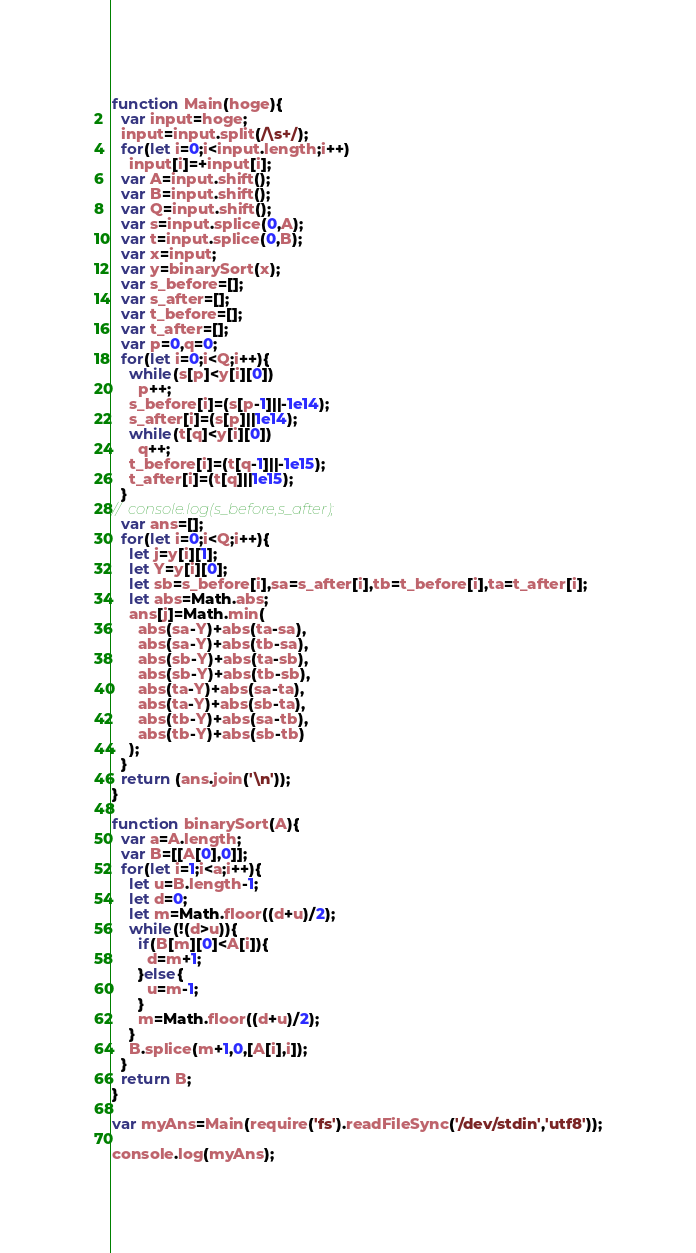<code> <loc_0><loc_0><loc_500><loc_500><_JavaScript_>function Main(hoge){
  var input=hoge;
  input=input.split(/\s+/);
  for(let i=0;i<input.length;i++)
    input[i]=+input[i];
  var A=input.shift();
  var B=input.shift();
  var Q=input.shift();
  var s=input.splice(0,A);
  var t=input.splice(0,B);
  var x=input;
  var y=binarySort(x);
  var s_before=[];
  var s_after=[];
  var t_before=[];
  var t_after=[];
  var p=0,q=0;
  for(let i=0;i<Q;i++){
    while(s[p]<y[i][0])
      p++;
    s_before[i]=(s[p-1]||-1e14);
    s_after[i]=(s[p]||1e14);
    while(t[q]<y[i][0])
      q++;
    t_before[i]=(t[q-1]||-1e15);
    t_after[i]=(t[q]||1e15);
  }
//  console.log(s_before,s_after);
  var ans=[];
  for(let i=0;i<Q;i++){
    let j=y[i][1];
    let Y=y[i][0];
    let sb=s_before[i],sa=s_after[i],tb=t_before[i],ta=t_after[i]; 
    let abs=Math.abs;
    ans[j]=Math.min(
      abs(sa-Y)+abs(ta-sa),
      abs(sa-Y)+abs(tb-sa),
      abs(sb-Y)+abs(ta-sb),
      abs(sb-Y)+abs(tb-sb),
      abs(ta-Y)+abs(sa-ta),
      abs(ta-Y)+abs(sb-ta),
      abs(tb-Y)+abs(sa-tb),
      abs(tb-Y)+abs(sb-tb)
    );
  }
  return (ans.join('\n'));
}

function binarySort(A){ 
  var a=A.length;
  var B=[[A[0],0]];
  for(let i=1;i<a;i++){
    let u=B.length-1;
    let d=0;
    let m=Math.floor((d+u)/2);
    while(!(d>u)){
      if(B[m][0]<A[i]){
        d=m+1;
      }else{
        u=m-1;
      }
      m=Math.floor((d+u)/2);
    }
    B.splice(m+1,0,[A[i],i]);
  }
  return B;
}

var myAns=Main(require('fs').readFileSync('/dev/stdin','utf8'));

console.log(myAns);
</code> 